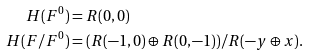Convert formula to latex. <formula><loc_0><loc_0><loc_500><loc_500>H ( F ^ { 0 } ) & = R ( 0 , 0 ) \\ H ( F / F ^ { 0 } ) & = ( R ( - 1 , 0 ) \oplus R ( 0 , - 1 ) ) / R ( - y \oplus x ) .</formula> 